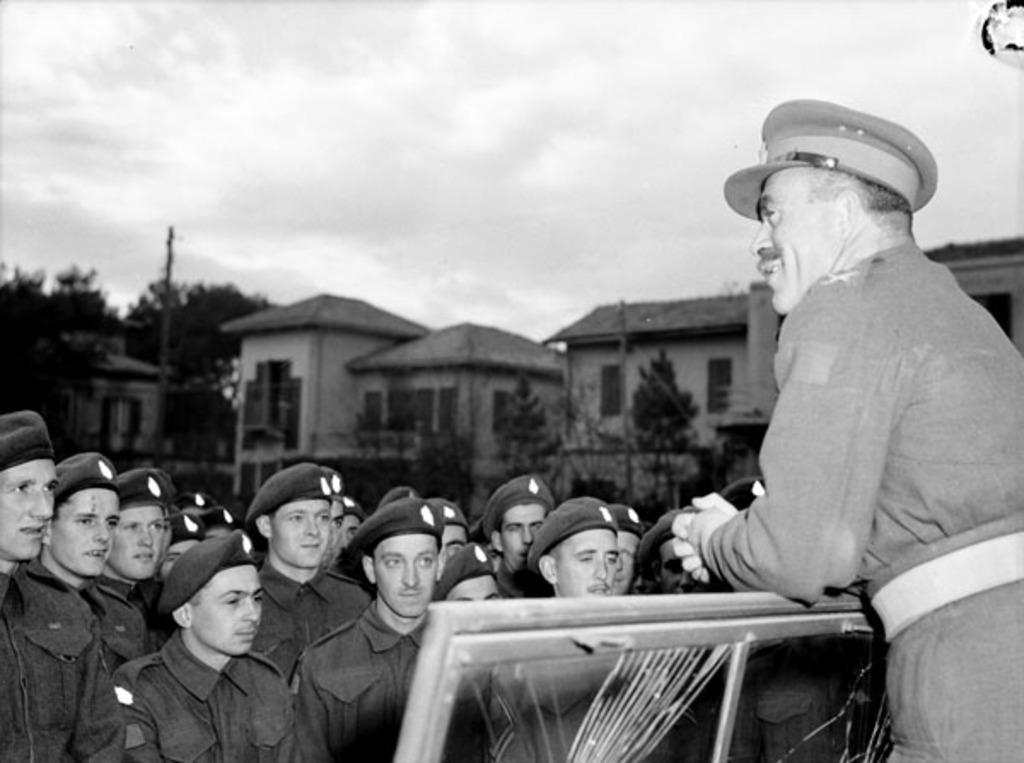What are the people in the image doing? The people in the image are standing on the ground. What type of natural elements can be seen in the image? There are trees in the image. What type of man-made structures are present in the image? There are buildings in the image. What is the tall, vertical object in the image? There is a pole in the image. What wooden object can be seen in the image? There is a wooden object in the image. What is visible in the background of the image? The sky is visible in the image. What type of celery is being used as a decoration in the image? There is no celery present in the image; it features people, trees, buildings, a pole, a wooden object, and the sky. What type of marble is visible on the ground in the image? There is no marble present in the image; the ground is not described in the provided facts. 